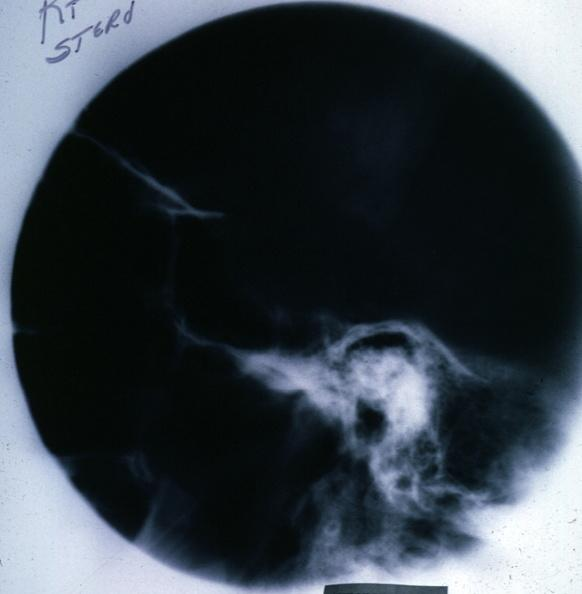what does this image show?
Answer the question using a single word or phrase. X-ray sella 